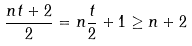<formula> <loc_0><loc_0><loc_500><loc_500>\frac { n t + 2 } { 2 } = n \frac { t } { 2 } + 1 \geq n + 2</formula> 